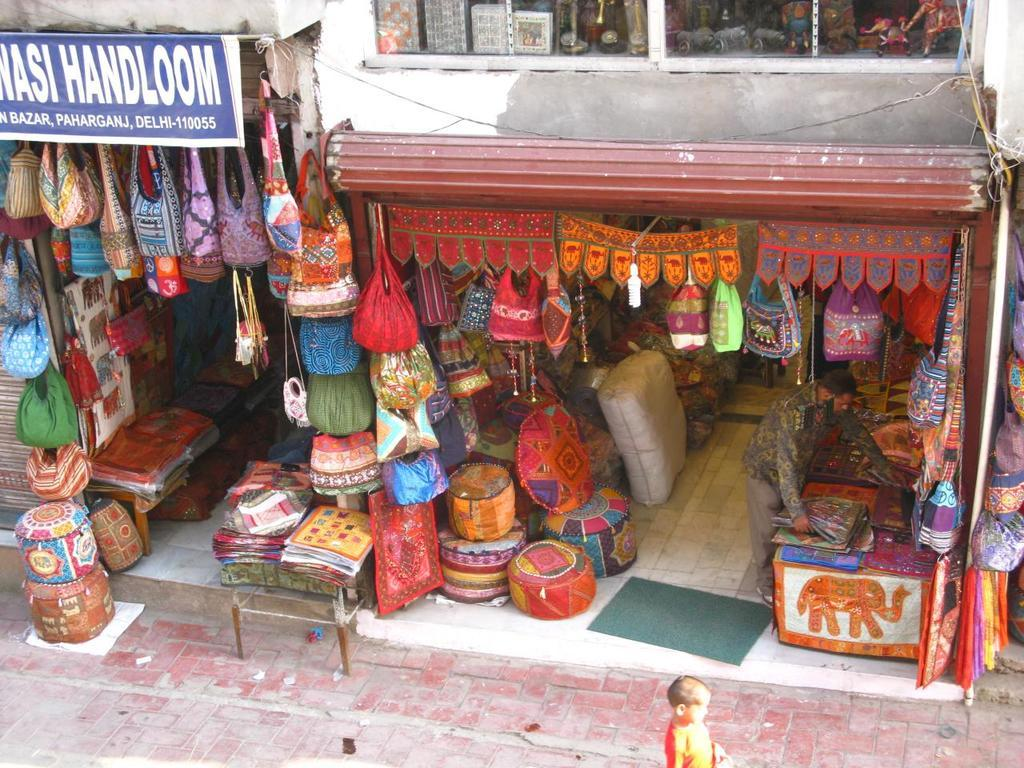<image>
Describe the image concisely. A child is walking in front of a bazar where a man is arranging new items. 